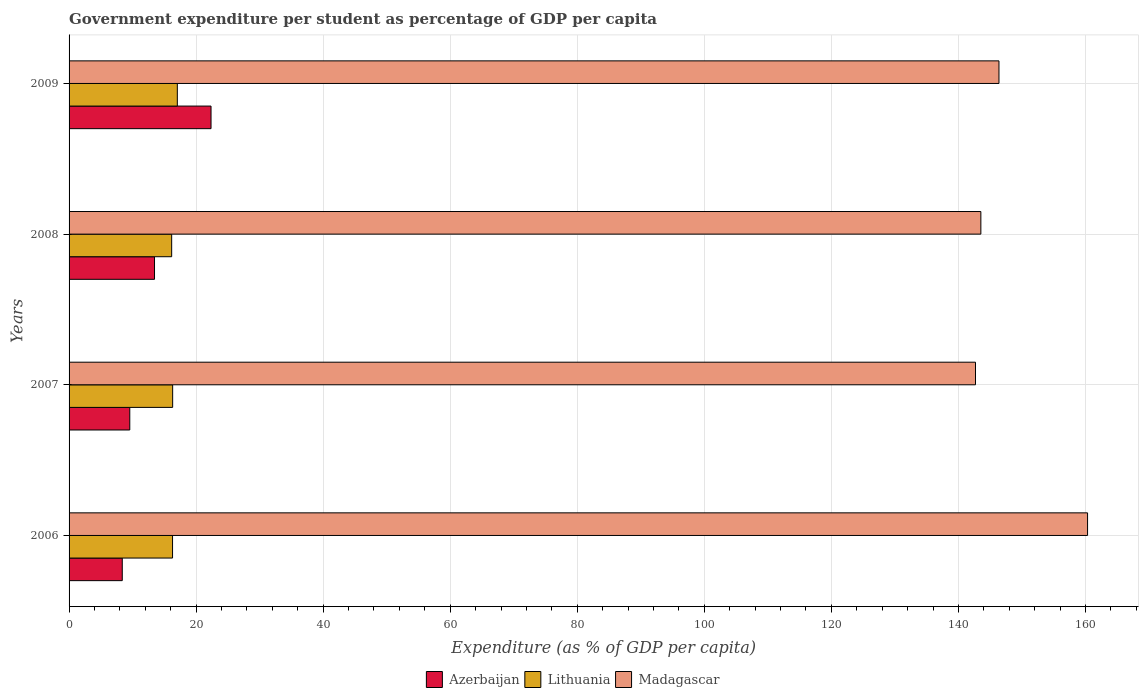How many different coloured bars are there?
Make the answer very short. 3. How many groups of bars are there?
Your answer should be very brief. 4. Are the number of bars per tick equal to the number of legend labels?
Your response must be concise. Yes. Are the number of bars on each tick of the Y-axis equal?
Your answer should be compact. Yes. How many bars are there on the 1st tick from the top?
Keep it short and to the point. 3. How many bars are there on the 4th tick from the bottom?
Give a very brief answer. 3. In how many cases, is the number of bars for a given year not equal to the number of legend labels?
Offer a terse response. 0. What is the percentage of expenditure per student in Lithuania in 2009?
Your answer should be very brief. 17.04. Across all years, what is the maximum percentage of expenditure per student in Lithuania?
Provide a succinct answer. 17.04. Across all years, what is the minimum percentage of expenditure per student in Azerbaijan?
Make the answer very short. 8.37. In which year was the percentage of expenditure per student in Madagascar maximum?
Offer a very short reply. 2006. In which year was the percentage of expenditure per student in Madagascar minimum?
Provide a succinct answer. 2007. What is the total percentage of expenditure per student in Lithuania in the graph?
Your answer should be very brief. 65.79. What is the difference between the percentage of expenditure per student in Madagascar in 2008 and that in 2009?
Your answer should be compact. -2.85. What is the difference between the percentage of expenditure per student in Azerbaijan in 2006 and the percentage of expenditure per student in Madagascar in 2009?
Give a very brief answer. -138.01. What is the average percentage of expenditure per student in Azerbaijan per year?
Ensure brevity in your answer.  13.43. In the year 2009, what is the difference between the percentage of expenditure per student in Azerbaijan and percentage of expenditure per student in Madagascar?
Keep it short and to the point. -124.04. What is the ratio of the percentage of expenditure per student in Azerbaijan in 2007 to that in 2008?
Your answer should be compact. 0.71. Is the percentage of expenditure per student in Lithuania in 2006 less than that in 2009?
Make the answer very short. Yes. What is the difference between the highest and the second highest percentage of expenditure per student in Madagascar?
Your answer should be compact. 13.95. What is the difference between the highest and the lowest percentage of expenditure per student in Lithuania?
Give a very brief answer. 0.89. Is the sum of the percentage of expenditure per student in Azerbaijan in 2006 and 2009 greater than the maximum percentage of expenditure per student in Lithuania across all years?
Offer a terse response. Yes. What does the 2nd bar from the top in 2009 represents?
Give a very brief answer. Lithuania. What does the 1st bar from the bottom in 2009 represents?
Your response must be concise. Azerbaijan. Is it the case that in every year, the sum of the percentage of expenditure per student in Lithuania and percentage of expenditure per student in Madagascar is greater than the percentage of expenditure per student in Azerbaijan?
Your answer should be compact. Yes. Are all the bars in the graph horizontal?
Offer a terse response. Yes. What is the difference between two consecutive major ticks on the X-axis?
Your answer should be very brief. 20. Does the graph contain any zero values?
Make the answer very short. No. Does the graph contain grids?
Provide a short and direct response. Yes. How many legend labels are there?
Ensure brevity in your answer.  3. How are the legend labels stacked?
Your response must be concise. Horizontal. What is the title of the graph?
Provide a short and direct response. Government expenditure per student as percentage of GDP per capita. Does "Andorra" appear as one of the legend labels in the graph?
Make the answer very short. No. What is the label or title of the X-axis?
Give a very brief answer. Expenditure (as % of GDP per capita). What is the label or title of the Y-axis?
Ensure brevity in your answer.  Years. What is the Expenditure (as % of GDP per capita) in Azerbaijan in 2006?
Give a very brief answer. 8.37. What is the Expenditure (as % of GDP per capita) in Lithuania in 2006?
Your answer should be compact. 16.29. What is the Expenditure (as % of GDP per capita) of Madagascar in 2006?
Make the answer very short. 160.33. What is the Expenditure (as % of GDP per capita) of Azerbaijan in 2007?
Provide a succinct answer. 9.56. What is the Expenditure (as % of GDP per capita) of Lithuania in 2007?
Keep it short and to the point. 16.31. What is the Expenditure (as % of GDP per capita) in Madagascar in 2007?
Your answer should be compact. 142.69. What is the Expenditure (as % of GDP per capita) of Azerbaijan in 2008?
Your answer should be very brief. 13.45. What is the Expenditure (as % of GDP per capita) in Lithuania in 2008?
Offer a very short reply. 16.15. What is the Expenditure (as % of GDP per capita) in Madagascar in 2008?
Your answer should be compact. 143.53. What is the Expenditure (as % of GDP per capita) in Azerbaijan in 2009?
Provide a succinct answer. 22.35. What is the Expenditure (as % of GDP per capita) of Lithuania in 2009?
Keep it short and to the point. 17.04. What is the Expenditure (as % of GDP per capita) of Madagascar in 2009?
Your answer should be compact. 146.38. Across all years, what is the maximum Expenditure (as % of GDP per capita) in Azerbaijan?
Provide a succinct answer. 22.35. Across all years, what is the maximum Expenditure (as % of GDP per capita) of Lithuania?
Your answer should be very brief. 17.04. Across all years, what is the maximum Expenditure (as % of GDP per capita) in Madagascar?
Provide a succinct answer. 160.33. Across all years, what is the minimum Expenditure (as % of GDP per capita) of Azerbaijan?
Your response must be concise. 8.37. Across all years, what is the minimum Expenditure (as % of GDP per capita) of Lithuania?
Give a very brief answer. 16.15. Across all years, what is the minimum Expenditure (as % of GDP per capita) of Madagascar?
Give a very brief answer. 142.69. What is the total Expenditure (as % of GDP per capita) in Azerbaijan in the graph?
Keep it short and to the point. 53.73. What is the total Expenditure (as % of GDP per capita) of Lithuania in the graph?
Provide a short and direct response. 65.79. What is the total Expenditure (as % of GDP per capita) of Madagascar in the graph?
Provide a succinct answer. 592.94. What is the difference between the Expenditure (as % of GDP per capita) in Azerbaijan in 2006 and that in 2007?
Offer a very short reply. -1.18. What is the difference between the Expenditure (as % of GDP per capita) in Lithuania in 2006 and that in 2007?
Keep it short and to the point. -0.02. What is the difference between the Expenditure (as % of GDP per capita) of Madagascar in 2006 and that in 2007?
Provide a short and direct response. 17.64. What is the difference between the Expenditure (as % of GDP per capita) of Azerbaijan in 2006 and that in 2008?
Ensure brevity in your answer.  -5.08. What is the difference between the Expenditure (as % of GDP per capita) in Lithuania in 2006 and that in 2008?
Keep it short and to the point. 0.14. What is the difference between the Expenditure (as % of GDP per capita) in Madagascar in 2006 and that in 2008?
Make the answer very short. 16.8. What is the difference between the Expenditure (as % of GDP per capita) of Azerbaijan in 2006 and that in 2009?
Your answer should be compact. -13.97. What is the difference between the Expenditure (as % of GDP per capita) in Lithuania in 2006 and that in 2009?
Give a very brief answer. -0.75. What is the difference between the Expenditure (as % of GDP per capita) of Madagascar in 2006 and that in 2009?
Your answer should be very brief. 13.95. What is the difference between the Expenditure (as % of GDP per capita) of Azerbaijan in 2007 and that in 2008?
Your response must be concise. -3.89. What is the difference between the Expenditure (as % of GDP per capita) of Lithuania in 2007 and that in 2008?
Offer a very short reply. 0.16. What is the difference between the Expenditure (as % of GDP per capita) of Madagascar in 2007 and that in 2008?
Give a very brief answer. -0.84. What is the difference between the Expenditure (as % of GDP per capita) of Azerbaijan in 2007 and that in 2009?
Offer a very short reply. -12.79. What is the difference between the Expenditure (as % of GDP per capita) in Lithuania in 2007 and that in 2009?
Provide a succinct answer. -0.73. What is the difference between the Expenditure (as % of GDP per capita) in Madagascar in 2007 and that in 2009?
Offer a terse response. -3.69. What is the difference between the Expenditure (as % of GDP per capita) in Azerbaijan in 2008 and that in 2009?
Your answer should be compact. -8.9. What is the difference between the Expenditure (as % of GDP per capita) of Lithuania in 2008 and that in 2009?
Ensure brevity in your answer.  -0.89. What is the difference between the Expenditure (as % of GDP per capita) of Madagascar in 2008 and that in 2009?
Provide a short and direct response. -2.85. What is the difference between the Expenditure (as % of GDP per capita) of Azerbaijan in 2006 and the Expenditure (as % of GDP per capita) of Lithuania in 2007?
Your answer should be compact. -7.93. What is the difference between the Expenditure (as % of GDP per capita) of Azerbaijan in 2006 and the Expenditure (as % of GDP per capita) of Madagascar in 2007?
Your response must be concise. -134.32. What is the difference between the Expenditure (as % of GDP per capita) of Lithuania in 2006 and the Expenditure (as % of GDP per capita) of Madagascar in 2007?
Make the answer very short. -126.4. What is the difference between the Expenditure (as % of GDP per capita) in Azerbaijan in 2006 and the Expenditure (as % of GDP per capita) in Lithuania in 2008?
Offer a very short reply. -7.78. What is the difference between the Expenditure (as % of GDP per capita) of Azerbaijan in 2006 and the Expenditure (as % of GDP per capita) of Madagascar in 2008?
Ensure brevity in your answer.  -135.16. What is the difference between the Expenditure (as % of GDP per capita) in Lithuania in 2006 and the Expenditure (as % of GDP per capita) in Madagascar in 2008?
Ensure brevity in your answer.  -127.24. What is the difference between the Expenditure (as % of GDP per capita) in Azerbaijan in 2006 and the Expenditure (as % of GDP per capita) in Lithuania in 2009?
Offer a terse response. -8.67. What is the difference between the Expenditure (as % of GDP per capita) of Azerbaijan in 2006 and the Expenditure (as % of GDP per capita) of Madagascar in 2009?
Make the answer very short. -138.01. What is the difference between the Expenditure (as % of GDP per capita) of Lithuania in 2006 and the Expenditure (as % of GDP per capita) of Madagascar in 2009?
Keep it short and to the point. -130.09. What is the difference between the Expenditure (as % of GDP per capita) in Azerbaijan in 2007 and the Expenditure (as % of GDP per capita) in Lithuania in 2008?
Give a very brief answer. -6.59. What is the difference between the Expenditure (as % of GDP per capita) of Azerbaijan in 2007 and the Expenditure (as % of GDP per capita) of Madagascar in 2008?
Keep it short and to the point. -133.98. What is the difference between the Expenditure (as % of GDP per capita) of Lithuania in 2007 and the Expenditure (as % of GDP per capita) of Madagascar in 2008?
Offer a terse response. -127.23. What is the difference between the Expenditure (as % of GDP per capita) of Azerbaijan in 2007 and the Expenditure (as % of GDP per capita) of Lithuania in 2009?
Your answer should be compact. -7.48. What is the difference between the Expenditure (as % of GDP per capita) of Azerbaijan in 2007 and the Expenditure (as % of GDP per capita) of Madagascar in 2009?
Provide a short and direct response. -136.83. What is the difference between the Expenditure (as % of GDP per capita) in Lithuania in 2007 and the Expenditure (as % of GDP per capita) in Madagascar in 2009?
Your answer should be very brief. -130.08. What is the difference between the Expenditure (as % of GDP per capita) of Azerbaijan in 2008 and the Expenditure (as % of GDP per capita) of Lithuania in 2009?
Give a very brief answer. -3.59. What is the difference between the Expenditure (as % of GDP per capita) in Azerbaijan in 2008 and the Expenditure (as % of GDP per capita) in Madagascar in 2009?
Your response must be concise. -132.93. What is the difference between the Expenditure (as % of GDP per capita) of Lithuania in 2008 and the Expenditure (as % of GDP per capita) of Madagascar in 2009?
Provide a short and direct response. -130.23. What is the average Expenditure (as % of GDP per capita) in Azerbaijan per year?
Offer a terse response. 13.43. What is the average Expenditure (as % of GDP per capita) of Lithuania per year?
Keep it short and to the point. 16.45. What is the average Expenditure (as % of GDP per capita) in Madagascar per year?
Your answer should be very brief. 148.23. In the year 2006, what is the difference between the Expenditure (as % of GDP per capita) of Azerbaijan and Expenditure (as % of GDP per capita) of Lithuania?
Offer a very short reply. -7.91. In the year 2006, what is the difference between the Expenditure (as % of GDP per capita) in Azerbaijan and Expenditure (as % of GDP per capita) in Madagascar?
Make the answer very short. -151.96. In the year 2006, what is the difference between the Expenditure (as % of GDP per capita) of Lithuania and Expenditure (as % of GDP per capita) of Madagascar?
Keep it short and to the point. -144.04. In the year 2007, what is the difference between the Expenditure (as % of GDP per capita) of Azerbaijan and Expenditure (as % of GDP per capita) of Lithuania?
Offer a terse response. -6.75. In the year 2007, what is the difference between the Expenditure (as % of GDP per capita) of Azerbaijan and Expenditure (as % of GDP per capita) of Madagascar?
Your response must be concise. -133.13. In the year 2007, what is the difference between the Expenditure (as % of GDP per capita) in Lithuania and Expenditure (as % of GDP per capita) in Madagascar?
Your answer should be compact. -126.38. In the year 2008, what is the difference between the Expenditure (as % of GDP per capita) in Azerbaijan and Expenditure (as % of GDP per capita) in Lithuania?
Provide a short and direct response. -2.7. In the year 2008, what is the difference between the Expenditure (as % of GDP per capita) in Azerbaijan and Expenditure (as % of GDP per capita) in Madagascar?
Keep it short and to the point. -130.08. In the year 2008, what is the difference between the Expenditure (as % of GDP per capita) of Lithuania and Expenditure (as % of GDP per capita) of Madagascar?
Offer a very short reply. -127.38. In the year 2009, what is the difference between the Expenditure (as % of GDP per capita) of Azerbaijan and Expenditure (as % of GDP per capita) of Lithuania?
Make the answer very short. 5.31. In the year 2009, what is the difference between the Expenditure (as % of GDP per capita) of Azerbaijan and Expenditure (as % of GDP per capita) of Madagascar?
Make the answer very short. -124.04. In the year 2009, what is the difference between the Expenditure (as % of GDP per capita) of Lithuania and Expenditure (as % of GDP per capita) of Madagascar?
Your response must be concise. -129.34. What is the ratio of the Expenditure (as % of GDP per capita) of Azerbaijan in 2006 to that in 2007?
Your answer should be compact. 0.88. What is the ratio of the Expenditure (as % of GDP per capita) of Madagascar in 2006 to that in 2007?
Make the answer very short. 1.12. What is the ratio of the Expenditure (as % of GDP per capita) in Azerbaijan in 2006 to that in 2008?
Ensure brevity in your answer.  0.62. What is the ratio of the Expenditure (as % of GDP per capita) of Lithuania in 2006 to that in 2008?
Offer a very short reply. 1.01. What is the ratio of the Expenditure (as % of GDP per capita) of Madagascar in 2006 to that in 2008?
Your answer should be compact. 1.12. What is the ratio of the Expenditure (as % of GDP per capita) of Azerbaijan in 2006 to that in 2009?
Make the answer very short. 0.37. What is the ratio of the Expenditure (as % of GDP per capita) of Lithuania in 2006 to that in 2009?
Your answer should be very brief. 0.96. What is the ratio of the Expenditure (as % of GDP per capita) in Madagascar in 2006 to that in 2009?
Your answer should be very brief. 1.1. What is the ratio of the Expenditure (as % of GDP per capita) of Azerbaijan in 2007 to that in 2008?
Your response must be concise. 0.71. What is the ratio of the Expenditure (as % of GDP per capita) in Lithuania in 2007 to that in 2008?
Your answer should be compact. 1.01. What is the ratio of the Expenditure (as % of GDP per capita) of Azerbaijan in 2007 to that in 2009?
Ensure brevity in your answer.  0.43. What is the ratio of the Expenditure (as % of GDP per capita) of Lithuania in 2007 to that in 2009?
Give a very brief answer. 0.96. What is the ratio of the Expenditure (as % of GDP per capita) of Madagascar in 2007 to that in 2009?
Provide a short and direct response. 0.97. What is the ratio of the Expenditure (as % of GDP per capita) in Azerbaijan in 2008 to that in 2009?
Your answer should be compact. 0.6. What is the ratio of the Expenditure (as % of GDP per capita) of Lithuania in 2008 to that in 2009?
Your answer should be compact. 0.95. What is the ratio of the Expenditure (as % of GDP per capita) of Madagascar in 2008 to that in 2009?
Your answer should be very brief. 0.98. What is the difference between the highest and the second highest Expenditure (as % of GDP per capita) of Azerbaijan?
Keep it short and to the point. 8.9. What is the difference between the highest and the second highest Expenditure (as % of GDP per capita) in Lithuania?
Your answer should be compact. 0.73. What is the difference between the highest and the second highest Expenditure (as % of GDP per capita) of Madagascar?
Your response must be concise. 13.95. What is the difference between the highest and the lowest Expenditure (as % of GDP per capita) of Azerbaijan?
Provide a succinct answer. 13.97. What is the difference between the highest and the lowest Expenditure (as % of GDP per capita) of Lithuania?
Provide a short and direct response. 0.89. What is the difference between the highest and the lowest Expenditure (as % of GDP per capita) in Madagascar?
Your answer should be compact. 17.64. 